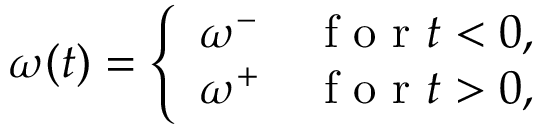Convert formula to latex. <formula><loc_0><loc_0><loc_500><loc_500>\begin{array} { r } { \omega ( t ) = \left \{ \begin{array} { l l } { \omega ^ { - } } & { f o r t < 0 , } \\ { \omega ^ { + } } & { f o r t > 0 , } \end{array} } \end{array}</formula> 